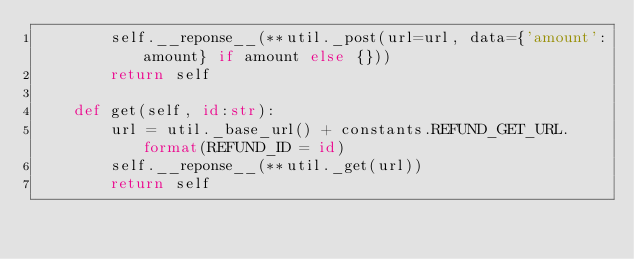Convert code to text. <code><loc_0><loc_0><loc_500><loc_500><_Python_>        self.__reponse__(**util._post(url=url, data={'amount':amount} if amount else {}))
        return self

    def get(self, id:str):
        url = util._base_url() + constants.REFUND_GET_URL.format(REFUND_ID = id)
        self.__reponse__(**util._get(url))
        return self
</code> 